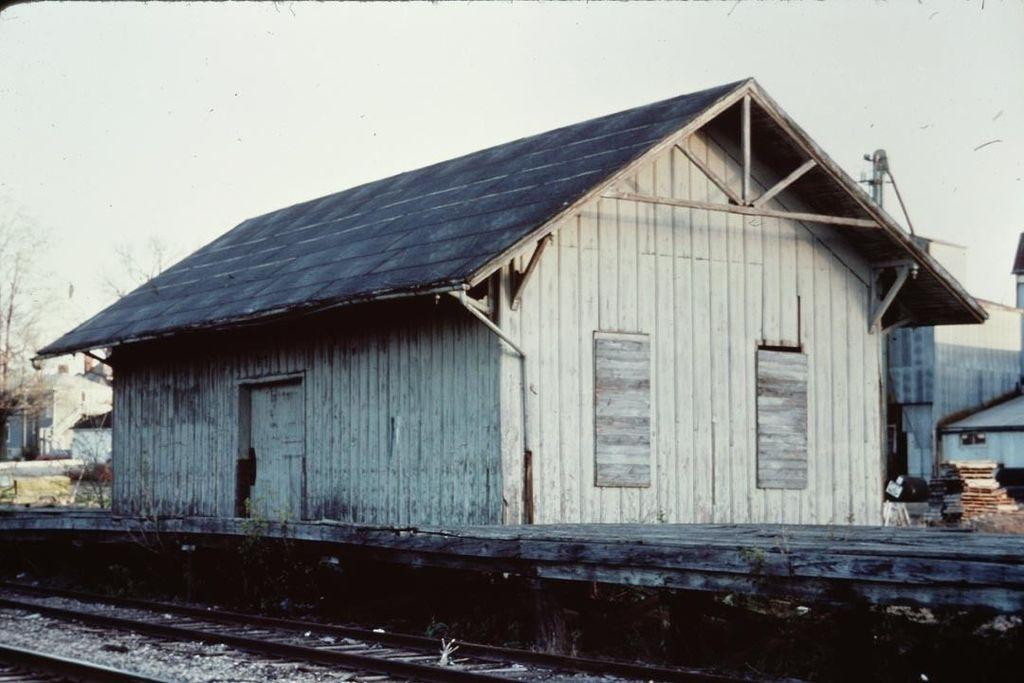What material is the house in the image made of? The house in the image is made of wood. What can be seen running parallel to the house in the image? There are railway tracks in the image. What is visible at the top of the image? The sky is visible at the top of the image. What type of nut is used to secure the lock on the house in the image? There is no lock or nut mentioned in the image; the house is made of wood and there are railway tracks nearby. 